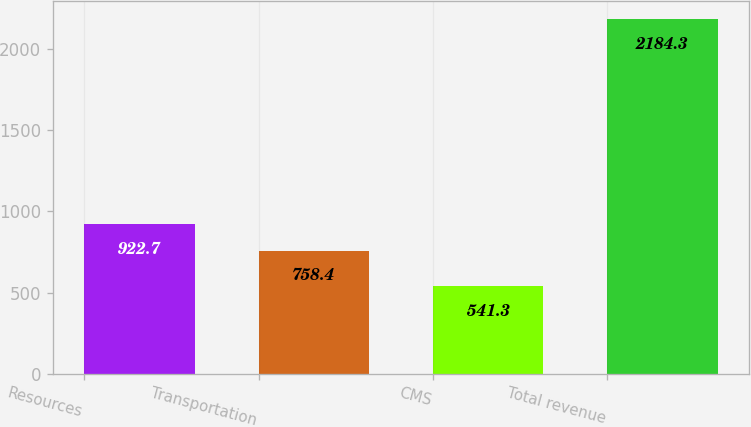Convert chart. <chart><loc_0><loc_0><loc_500><loc_500><bar_chart><fcel>Resources<fcel>Transportation<fcel>CMS<fcel>Total revenue<nl><fcel>922.7<fcel>758.4<fcel>541.3<fcel>2184.3<nl></chart> 